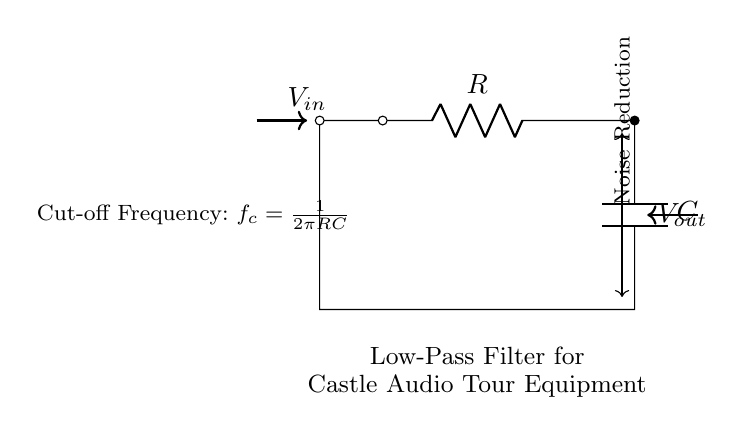What type of filter is represented in the circuit? The circuit is a low-pass filter, designed to allow low-frequency signals to pass while attenuating high-frequency signals. This is indicated by the labeling in the circuit diagram.
Answer: Low-pass filter What are the two components in this circuit? The circuit consists of a resistor and a capacitor. These components are clearly labeled as "R" for the resistor and "C" for the capacitor in the diagram.
Answer: Resistor and Capacitor What is the purpose of this circuit? The purpose of the circuit is to reduce noise in audio tour equipment, as indicated in the caption of the diagram. This noise reduction is achieved through the filtering properties of the low-pass filter, which is designed to smooth out the audio signal.
Answer: Noise reduction How is the cut-off frequency calculated? The cut-off frequency is calculated using the formula f_c = 1/(2πRC), which is noted in the diagram. This formula indicates how the frequency at which the output signal begins to decrease is determined by the values of the resistor and capacitor.
Answer: f_c = 1/(2πRC) What would happen if the resistance is increased? Increasing the resistance would lower the cut-off frequency, thus allowing only lower frequencies to pass through effectively. This relation is derived from the cut-off frequency formula, where resistance and capacitance directly influence the frequency response of the circuit.
Answer: Lower cut-off frequency What role does the capacitor play in this circuit? The capacitor stores and releases electrical energy, which helps smooth out the output voltage by filtering out the high-frequency noise, allowing only desired lower frequencies to pass through. This behavior is characteristic of capacitors in low-pass filters.
Answer: Smoothing output voltage Which direction does the output voltage flow in the circuit? The output voltage flows from the capacitor to the output node, as shown by the arrow indicating the direction of the output voltage in the diagram. This shows the signal flow from the filtered output back to the measurement or load.
Answer: From capacitor to output node 